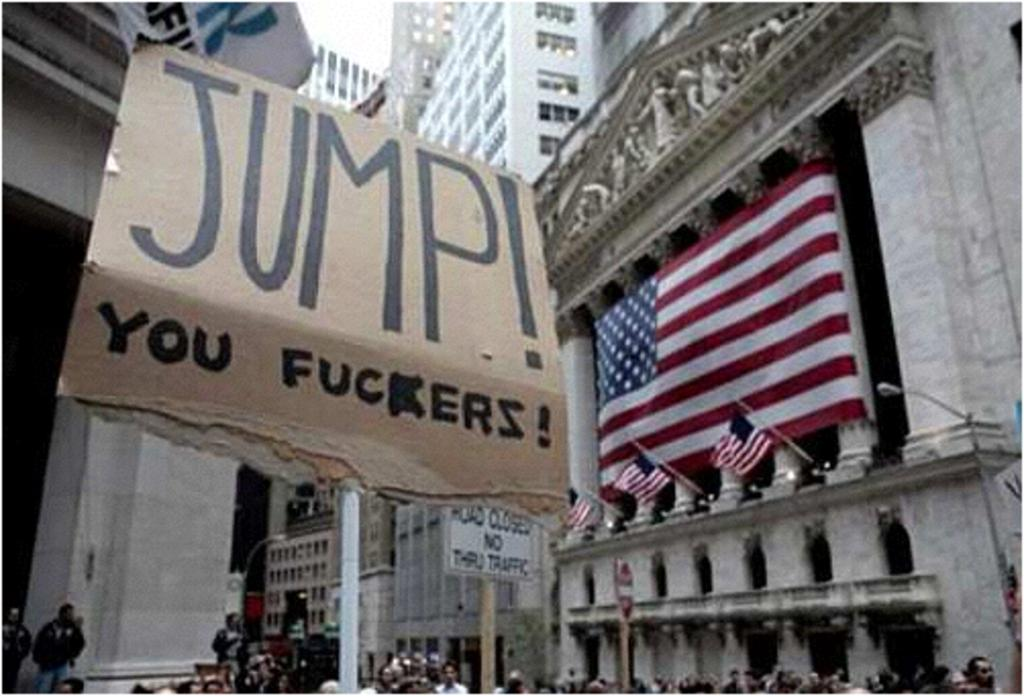How many people can be seen in the image? There are many people in the image. What are the people holding in the image? The people are holding placards in the image. What can be seen on a vertical surface in the image? There is a sign board in the image. What national symbol is present in the image? There are U.S. flags in the image. What type of structures can be seen in the background of the image? There are buildings in the image. What type of sweater is the father wearing in the image? There is no father or sweater present in the image. What industry is depicted in the image? The image does not depict any specific industry; it features people, placards, a sign board, U.S. flags, and buildings. 